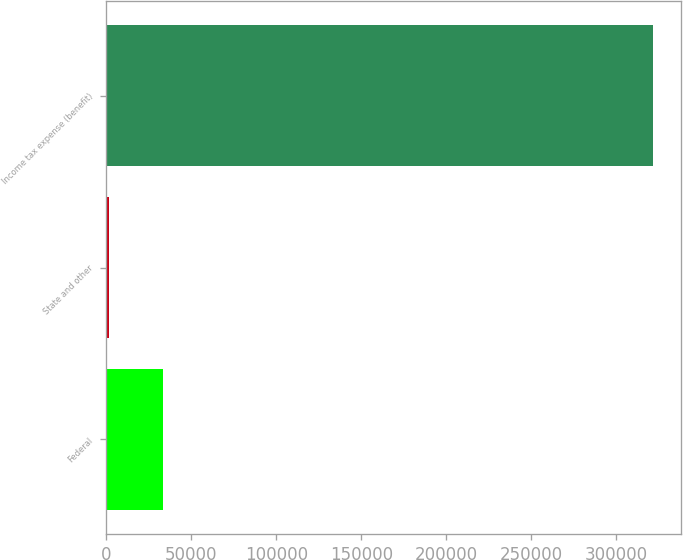<chart> <loc_0><loc_0><loc_500><loc_500><bar_chart><fcel>Federal<fcel>State and other<fcel>Income tax expense (benefit)<nl><fcel>33519.9<fcel>1474<fcel>321933<nl></chart> 